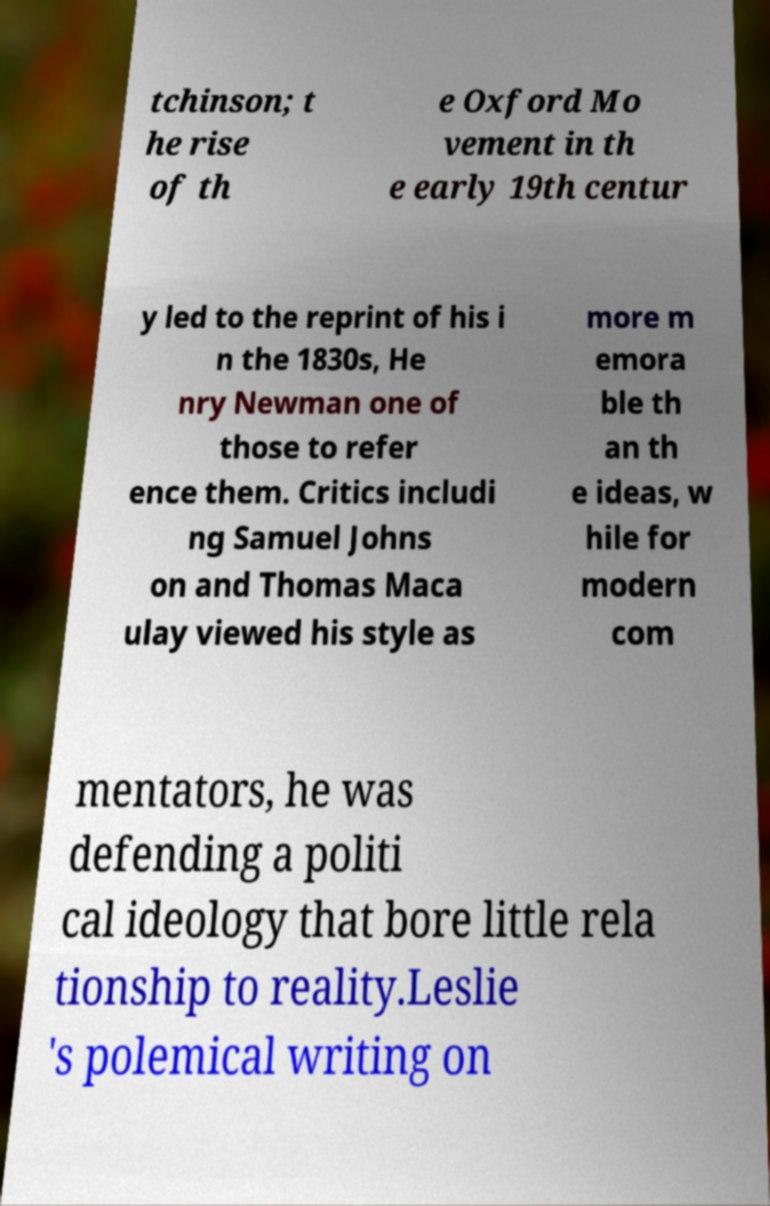Could you assist in decoding the text presented in this image and type it out clearly? tchinson; t he rise of th e Oxford Mo vement in th e early 19th centur y led to the reprint of his i n the 1830s, He nry Newman one of those to refer ence them. Critics includi ng Samuel Johns on and Thomas Maca ulay viewed his style as more m emora ble th an th e ideas, w hile for modern com mentators, he was defending a politi cal ideology that bore little rela tionship to reality.Leslie 's polemical writing on 